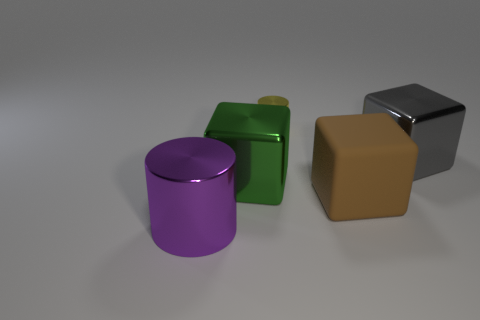Is the green metallic thing the same shape as the gray thing?
Offer a very short reply. Yes. Is there any other thing that has the same shape as the large green object?
Give a very brief answer. Yes. Is the cylinder in front of the yellow metal thing made of the same material as the gray cube?
Keep it short and to the point. Yes. What is the shape of the large thing that is both behind the brown cube and in front of the large gray metallic thing?
Your answer should be compact. Cube. There is a big metallic object that is in front of the big green cube; is there a cylinder that is left of it?
Make the answer very short. No. What number of other things are there of the same material as the small cylinder
Provide a succinct answer. 3. Is the shape of the metallic thing on the right side of the yellow metallic object the same as the large green thing that is in front of the small yellow cylinder?
Offer a terse response. Yes. Does the large brown block have the same material as the big gray block?
Provide a short and direct response. No. There is a cylinder in front of the cylinder right of the shiny cylinder that is on the left side of the small yellow metal thing; what size is it?
Your response must be concise. Large. What number of other objects are the same color as the big matte object?
Keep it short and to the point. 0. 